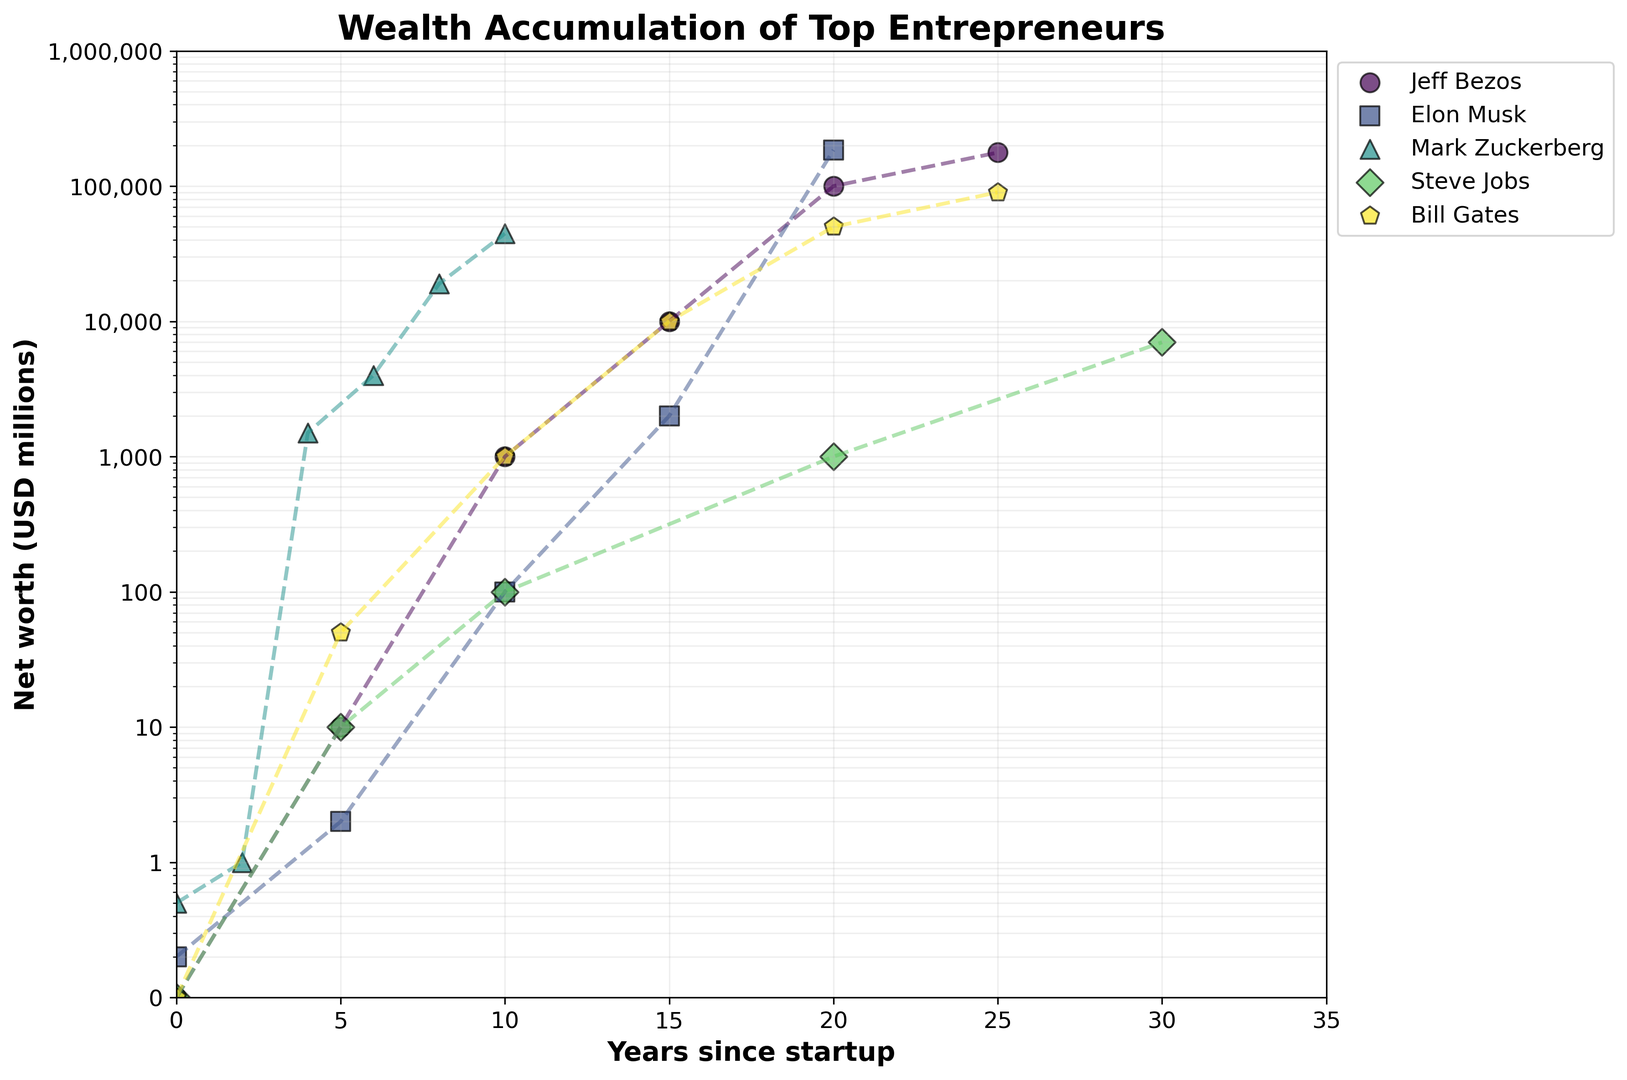What is the net worth of Jeff Bezos at 10 years since startup? Look at the data points for Jeff Bezos and locate the one at 10 years, corresponding to a net worth.
Answer: 1000 million USD How does Bill Gates' net worth compare to Steve Jobs' at 20 years since startup? Find the net worth values for both Bill Gates and Steve Jobs at 20 years. Bill Gates has 50,000 million USD, while Steve Jobs has 1,000 million USD. Therefore, Bill Gates has a higher net worth.
Answer: Bill Gates has a higher net worth Which entrepreneur achieved the fastest growth in net worth within the first 10 years? Compare the net worth of all entrepreneurs at 10 years. Jeff Bezos' net worth grew fastest to 1,000 million USD.
Answer: Jeff Bezos How many entrepreneurs had a net worth of at least 1,000 million USD by 10 years since startup? Identify all entrepreneurs and check their net worth at 10 years, counting those with at least 1,000 million USD: Jeff Bezos, Bill Gates, and Mark Zuckerberg.
Answer: 3 What is the general trend in the net worth of Elon Musk from 15 to 20 years since startup? Observe the plotted line for Elon Musk from the 15-year mark to the 20-year mark, which indicates a sharp increase from 2,000 million to 185,000 million USD.
Answer: Sharp increase Compare the net worth growth between Mark Zuckerberg and Jeff Bezos in their first 5 years. Look at the net worth values of Mark Zuckerberg and Jeff Bezos at 0 and 5 years. Mark Zuckerberg went from 0.5 million to 1 million USD, while Jeff Bezos went from 0.1 million to 10 million USD. Bezos had a larger growth.
Answer: Jeff Bezos Which entrepreneur had the highest net worth after 25 years since startup? Check the net worth values at 25 years for all entrepreneurs. Jeff Bezos has 177,000 million USD, which is the highest.
Answer: Jeff Bezos Between which years did Steve Jobs experience a significant increase in net worth? Examine the plotted points for Steve Jobs. A significant increase is observed between 20 to 30 years, from 1,000 million to 7,000 million USD.
Answer: Between 20 to 30 years What color represents Elon Musk's data points on the plot? Observe the color assigned to the data points and line representing Elon Musk.
Answer: (Based on the colormap, Elon Musk might be represented by a specific color from the viridis palette; visually confirm from the plot.) What is the range of net worth values present in the first 5 years for all entrepreneurs? Look at the net worth values for all entrepreneurs in their first 5 years, ranging from 0.1 million to 50 million USD.
Answer: 0.1 to 50 million USD 